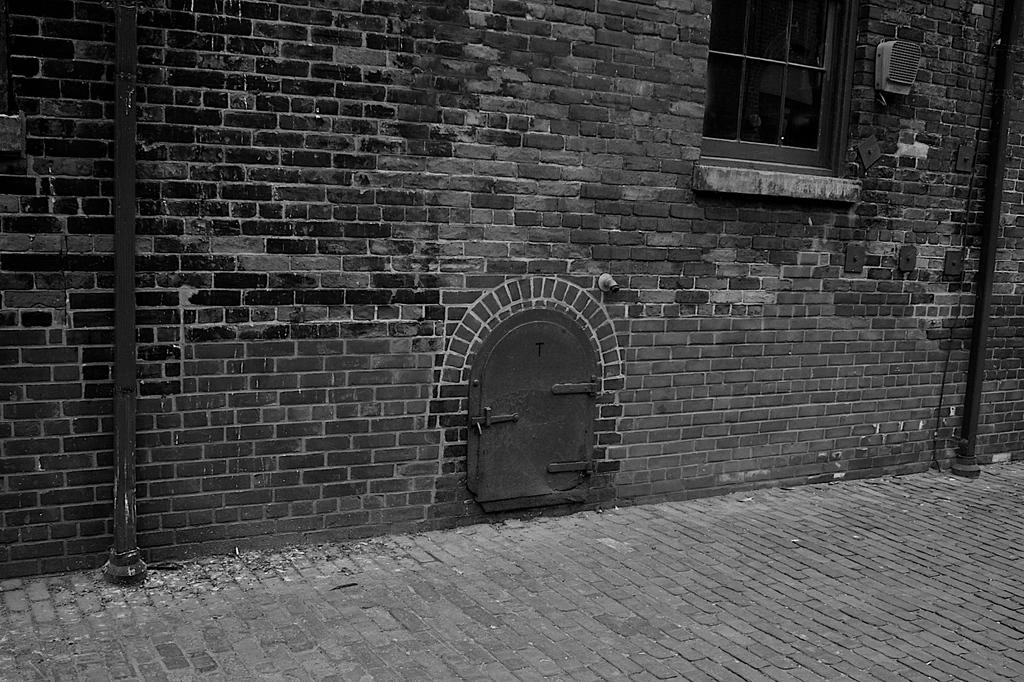What type of structure is visible in the image? There is a building in the image. What part of the building can be seen in the image? There is a window in the image. What material is used for the wall of the building? There is a brick wall in the image. What other object is present in the image? There is a pole in the image. How is the image presented in terms of color? The image is in black and white. Where is the rake being used in the image? There is no rake present in the image. What type of stem can be seen growing from the brick wall in the image? There are no stems growing from the brick wall in the image. 